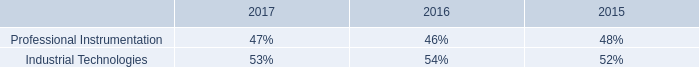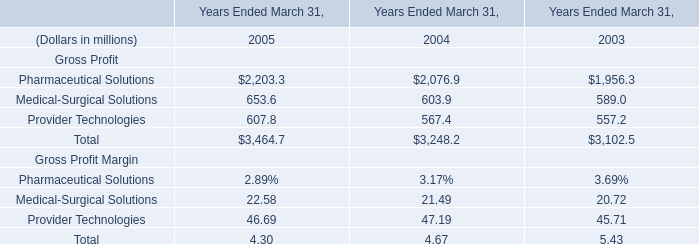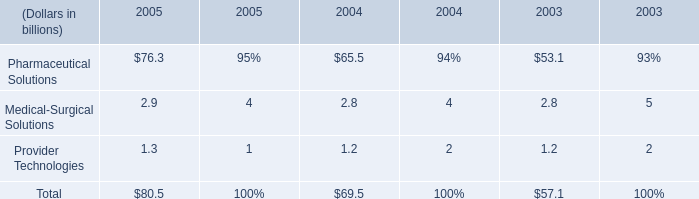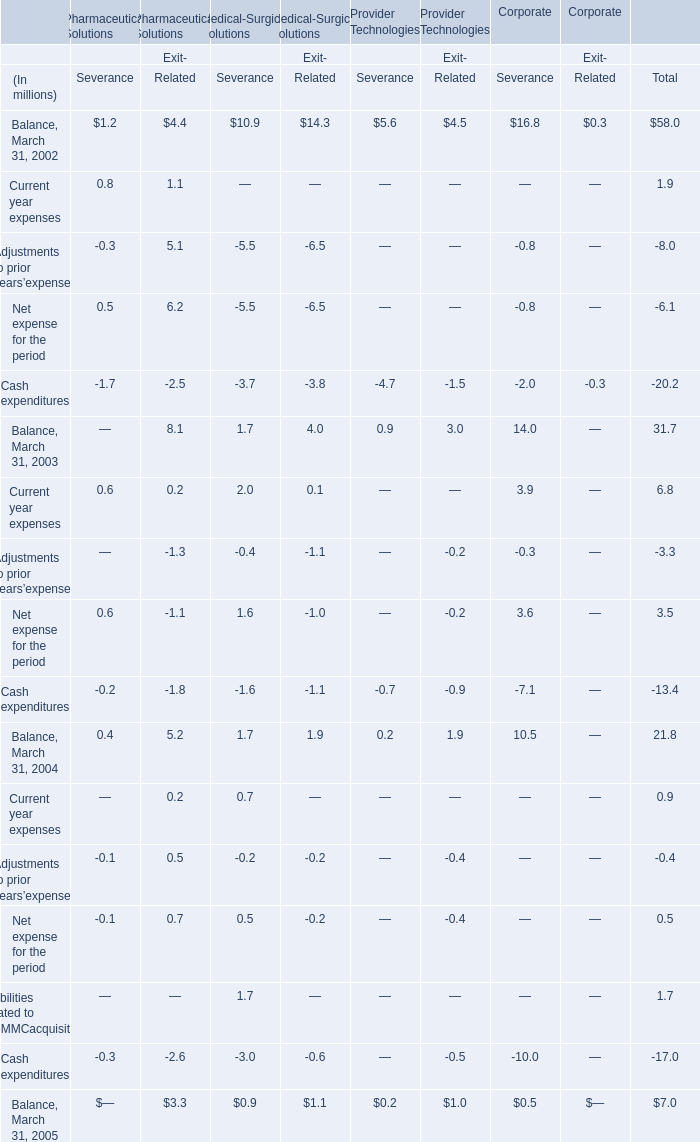What was the average of the Adjustments to prior years’expenses in the years where Current year expenses is positive? (in million) 
Computations: (((-3.3 - 0.4) - 8.0) / 3)
Answer: -3.9. 